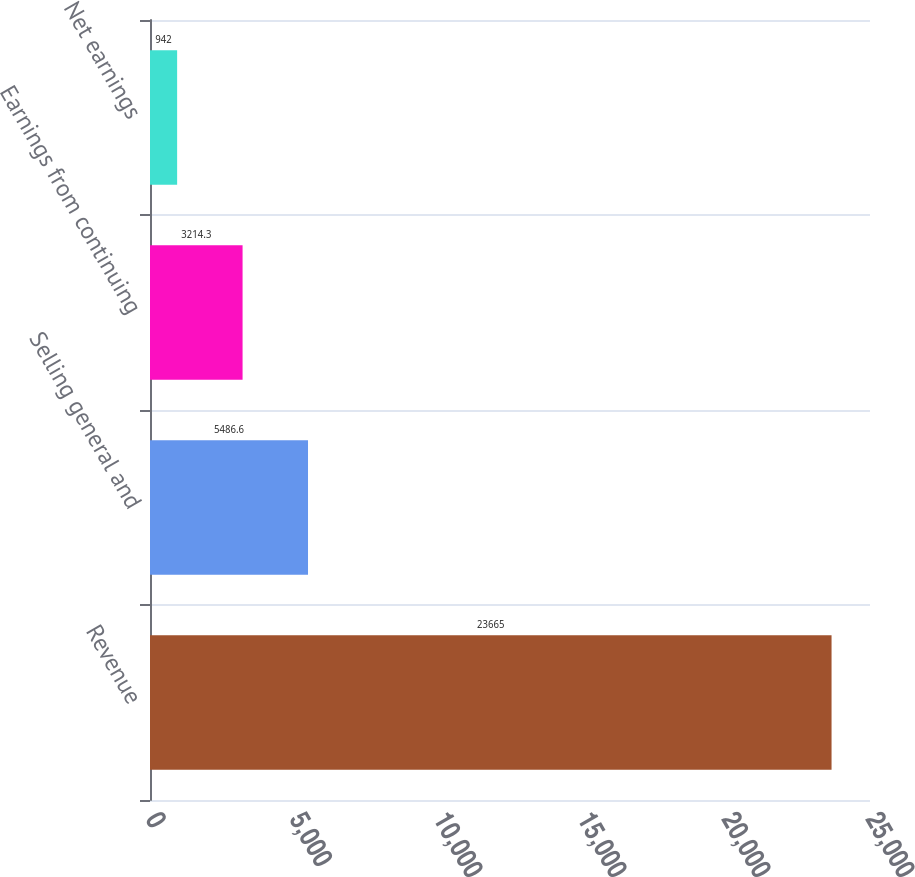Convert chart to OTSL. <chart><loc_0><loc_0><loc_500><loc_500><bar_chart><fcel>Revenue<fcel>Selling general and<fcel>Earnings from continuing<fcel>Net earnings<nl><fcel>23665<fcel>5486.6<fcel>3214.3<fcel>942<nl></chart> 